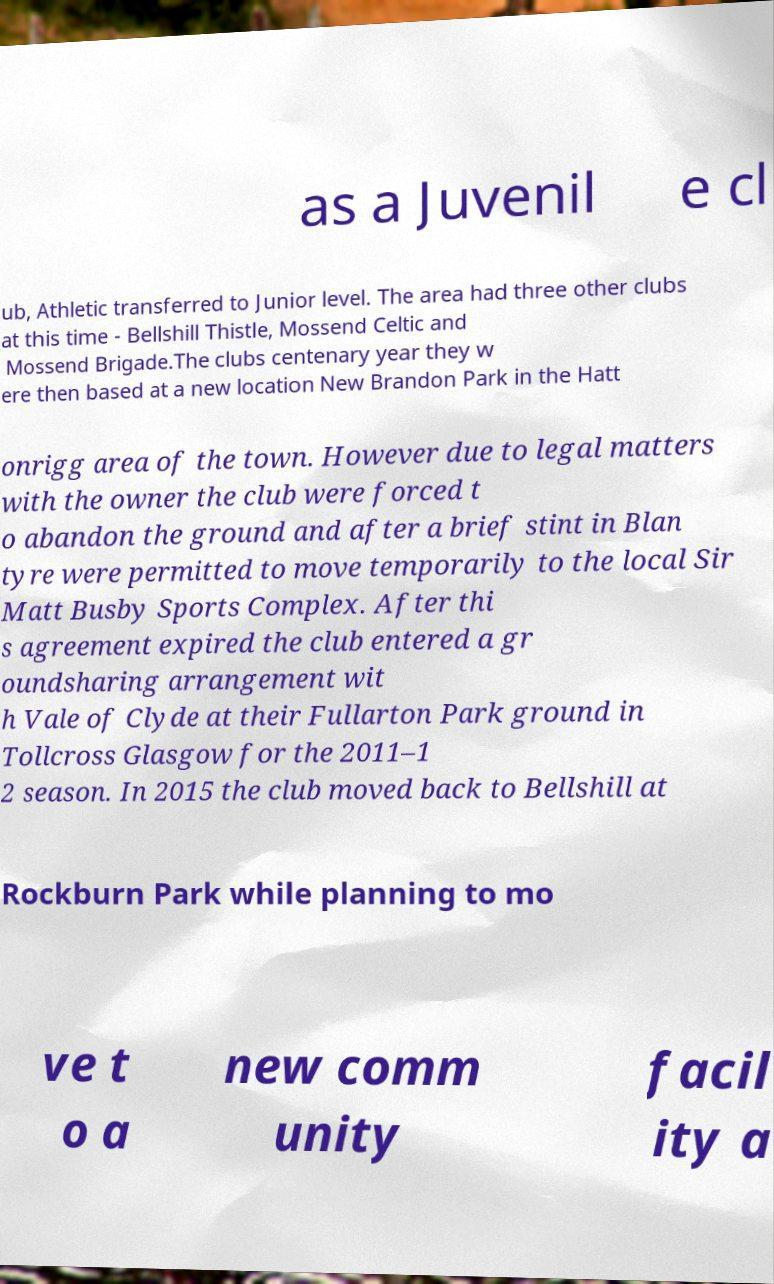Please read and relay the text visible in this image. What does it say? as a Juvenil e cl ub, Athletic transferred to Junior level. The area had three other clubs at this time - Bellshill Thistle, Mossend Celtic and Mossend Brigade.The clubs centenary year they w ere then based at a new location New Brandon Park in the Hatt onrigg area of the town. However due to legal matters with the owner the club were forced t o abandon the ground and after a brief stint in Blan tyre were permitted to move temporarily to the local Sir Matt Busby Sports Complex. After thi s agreement expired the club entered a gr oundsharing arrangement wit h Vale of Clyde at their Fullarton Park ground in Tollcross Glasgow for the 2011–1 2 season. In 2015 the club moved back to Bellshill at Rockburn Park while planning to mo ve t o a new comm unity facil ity a 